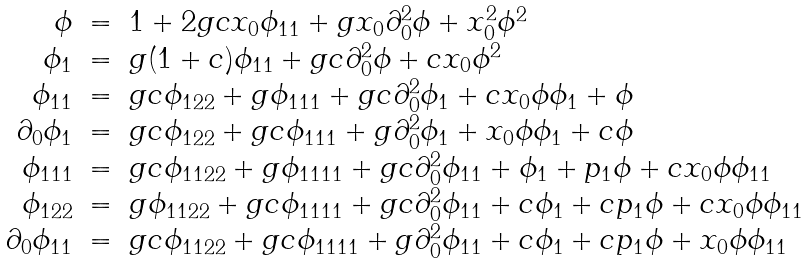Convert formula to latex. <formula><loc_0><loc_0><loc_500><loc_500>\begin{array} { r c l } \phi & = & 1 + 2 g c x _ { 0 } \phi _ { 1 1 } + g x _ { 0 } \partial _ { 0 } ^ { 2 } \phi + x _ { 0 } ^ { 2 } \phi ^ { 2 } \\ \phi _ { 1 } & = & g ( 1 + c ) \phi _ { 1 1 } + g c \partial _ { 0 } ^ { 2 } \phi + c x _ { 0 } \phi ^ { 2 } \\ \phi _ { 1 1 } & = & g c \phi _ { 1 2 2 } + g \phi _ { 1 1 1 } + g c \partial ^ { 2 } _ { 0 } \phi _ { 1 } + c x _ { 0 } \phi \phi _ { 1 } + \phi \\ \partial _ { 0 } \phi _ { 1 } & = & g c \phi _ { 1 2 2 } + g c \phi _ { 1 1 1 } + g \partial ^ { 2 } _ { 0 } \phi _ { 1 } + x _ { 0 } \phi \phi _ { 1 } + c \phi \\ \phi _ { 1 1 1 } & = & g c \phi _ { 1 1 2 2 } + g \phi _ { 1 1 1 1 } + g c \partial ^ { 2 } _ { 0 } \phi _ { 1 1 } + \phi _ { 1 } + p _ { 1 } \phi + c x _ { 0 } \phi \phi _ { 1 1 } \\ \phi _ { 1 2 2 } & = & g \phi _ { 1 1 2 2 } + g c \phi _ { 1 1 1 1 } + g c \partial ^ { 2 } _ { 0 } \phi _ { 1 1 } + c \phi _ { 1 } + c p _ { 1 } \phi + c x _ { 0 } \phi \phi _ { 1 1 } \\ \partial _ { 0 } \phi _ { 1 1 } & = & g c \phi _ { 1 1 2 2 } + g c \phi _ { 1 1 1 1 } + g \partial _ { 0 } ^ { 2 } \phi _ { 1 1 } + c \phi _ { 1 } + c p _ { 1 } \phi + x _ { 0 } \phi \phi _ { 1 1 } \end{array} \label l { e q \colon 3 s p 7 }</formula> 